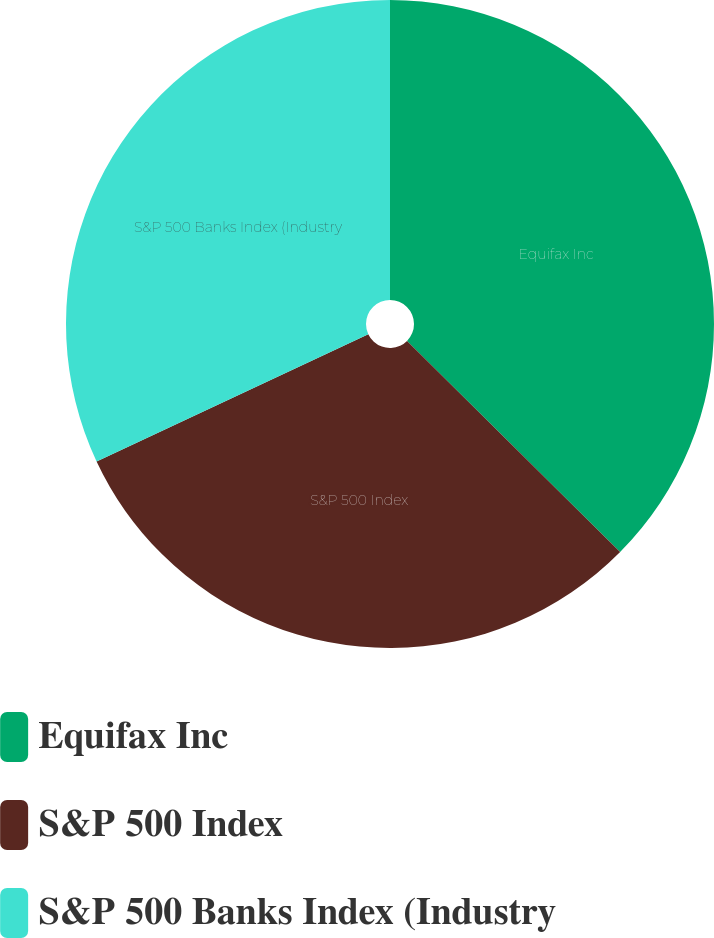<chart> <loc_0><loc_0><loc_500><loc_500><pie_chart><fcel>Equifax Inc<fcel>S&P 500 Index<fcel>S&P 500 Banks Index (Industry<nl><fcel>37.43%<fcel>30.6%<fcel>31.97%<nl></chart> 